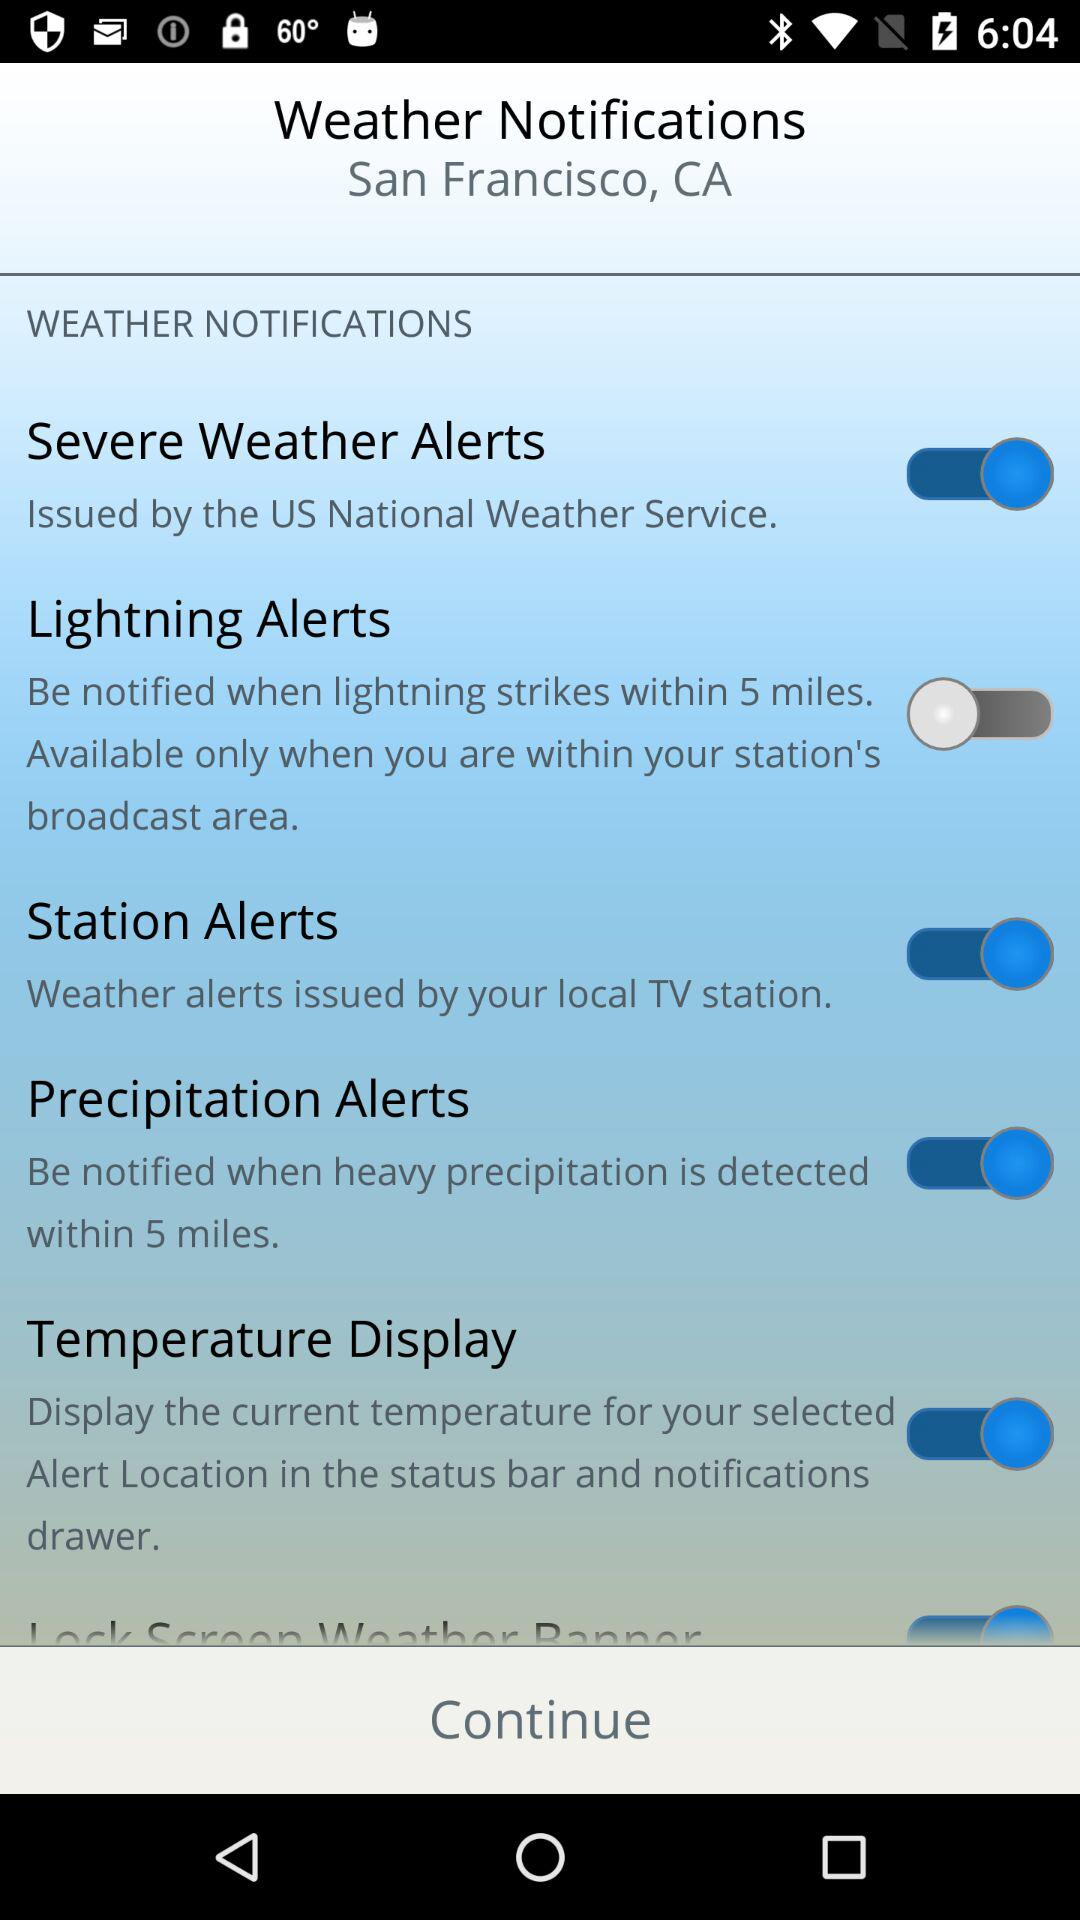What is the location? The location is San Francisco, CA. 